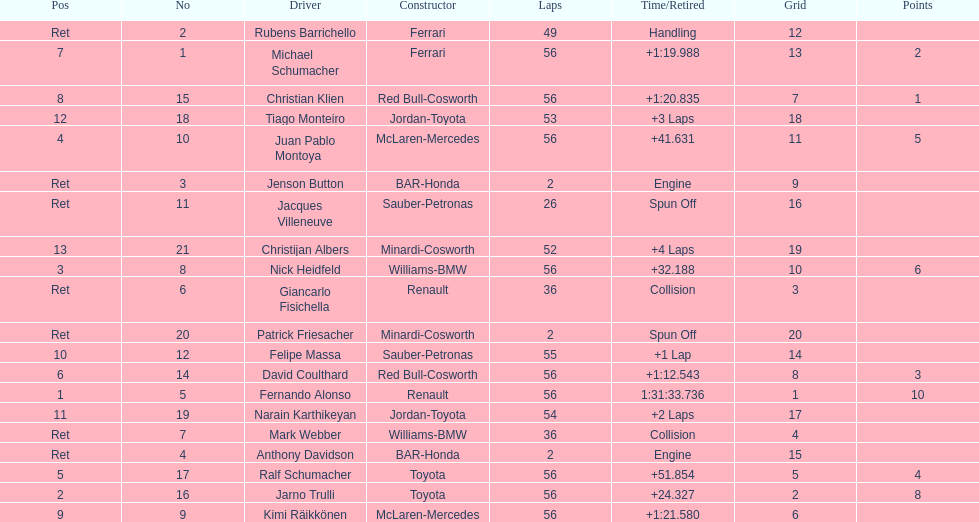What was the overall number of laps finished by the 1st place victor? 56. 